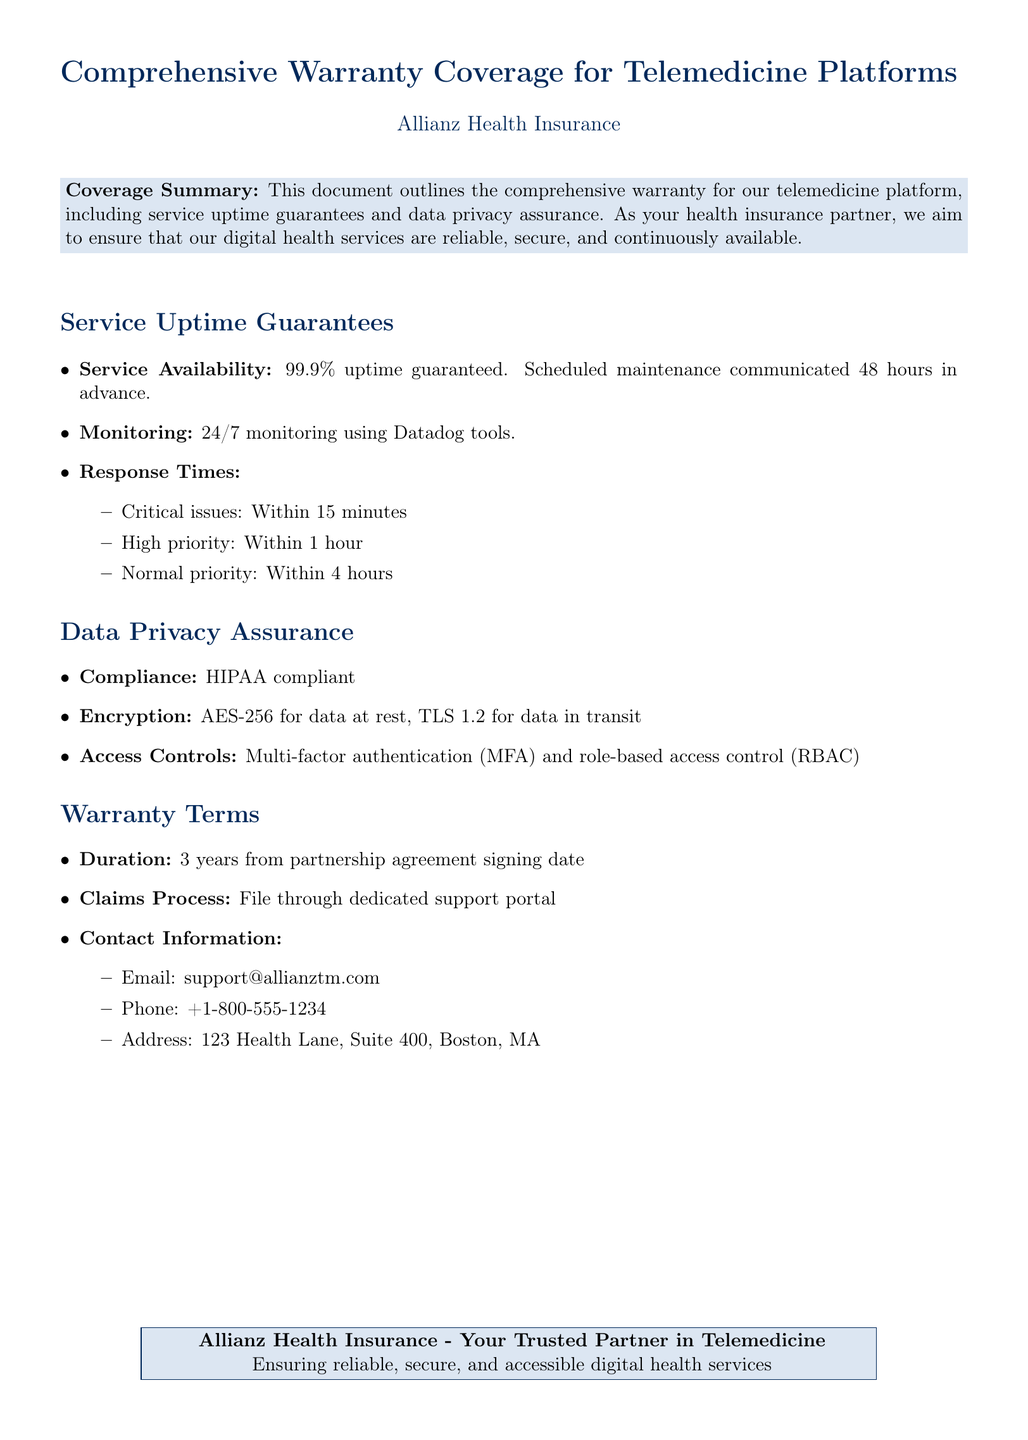what is the uptime guarantee The document states that the uptime guarantee for the telemedicine platform is 99.9%.
Answer: 99.9% how often is scheduled maintenance communicated Maintenance notifications are communicated 48 hours in advance.
Answer: 48 hours what is the response time for critical issues The response time for critical issues is within 15 minutes.
Answer: 15 minutes what encryption method is used for data at rest The encryption method for data at rest is AES-256.
Answer: AES-256 how long is the warranty duration The duration of the warranty is 3 years from the partnership agreement signing date.
Answer: 3 years which compliance standard is mentioned The document mentions compliance with HIPAA.
Answer: HIPAA what type of access control is used The access control methods include multi-factor authentication and role-based access control.
Answer: Multi-factor authentication and role-based access control how can claims be filed Claims should be filed through a dedicated support portal.
Answer: Support portal what is the contact phone number The contact phone number listed is +1-800-555-1234.
Answer: +1-800-555-1234 